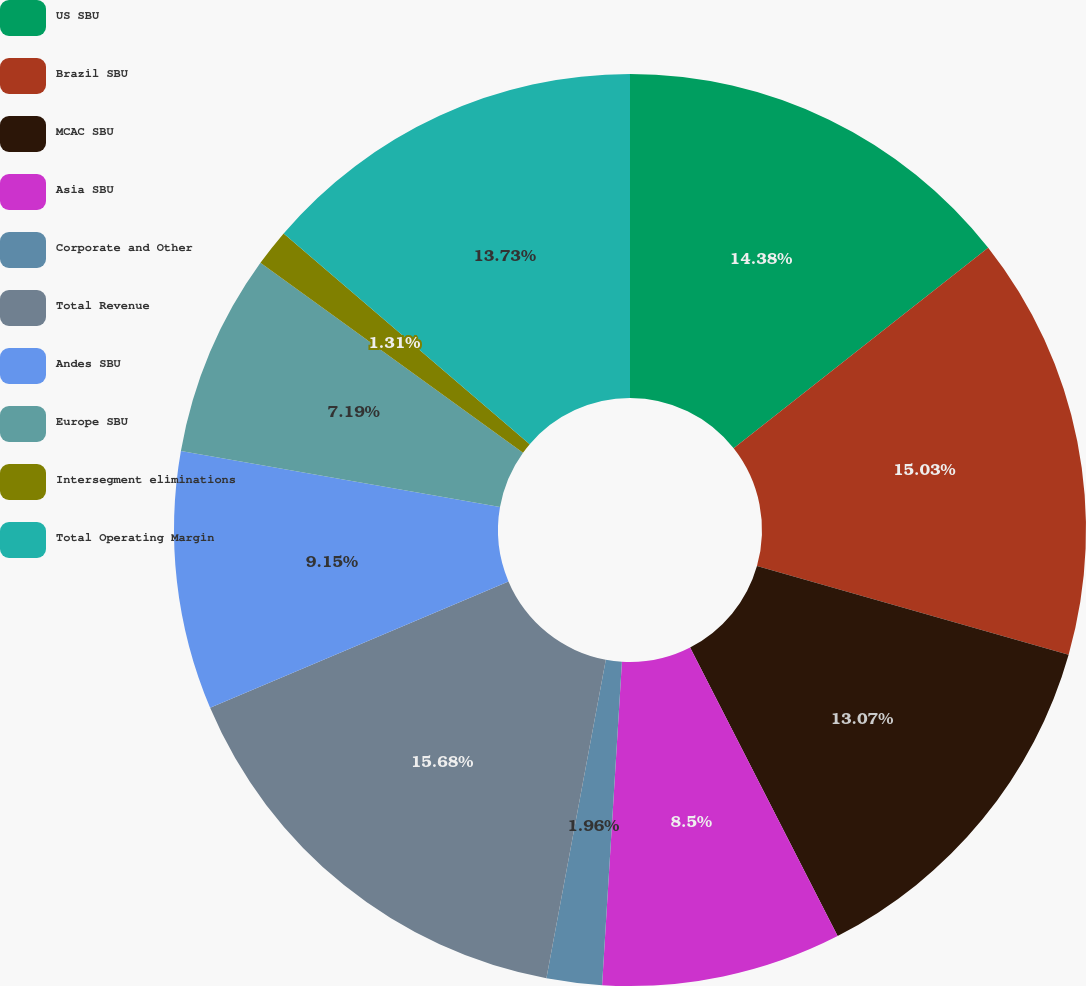<chart> <loc_0><loc_0><loc_500><loc_500><pie_chart><fcel>US SBU<fcel>Brazil SBU<fcel>MCAC SBU<fcel>Asia SBU<fcel>Corporate and Other<fcel>Total Revenue<fcel>Andes SBU<fcel>Europe SBU<fcel>Intersegment eliminations<fcel>Total Operating Margin<nl><fcel>14.38%<fcel>15.03%<fcel>13.07%<fcel>8.5%<fcel>1.96%<fcel>15.69%<fcel>9.15%<fcel>7.19%<fcel>1.31%<fcel>13.73%<nl></chart> 